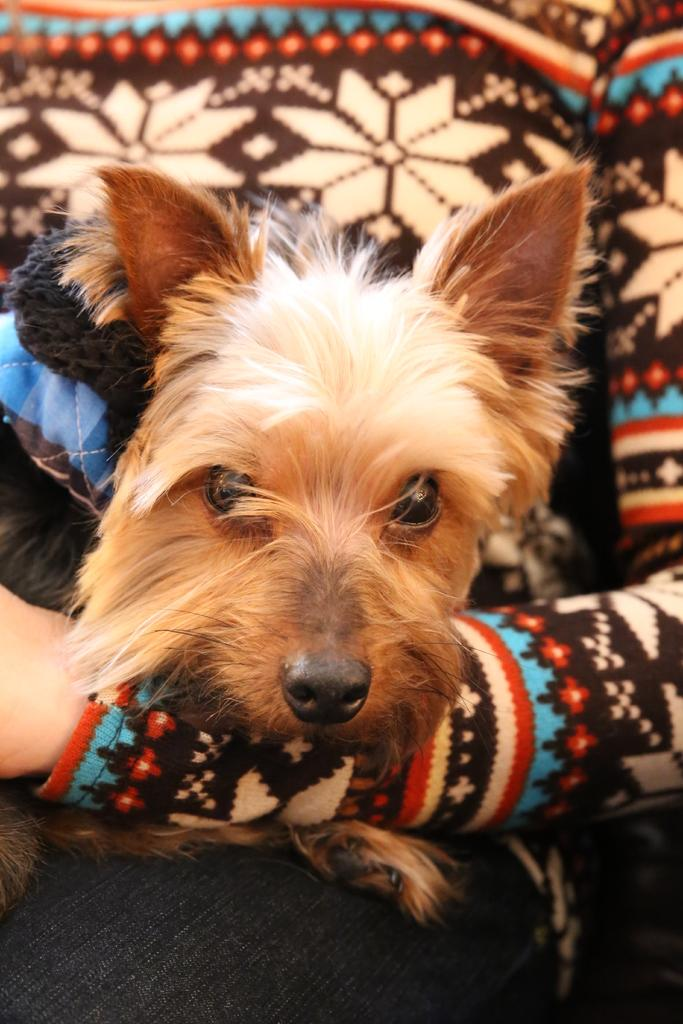What is the main subject of the image? There is a person in the image. What is the person doing in the image? The person is holding a dog. What type of paper is the person reading on their vacation with their friend? There is no paper or friend present in the image; it only shows a person holding a dog. 